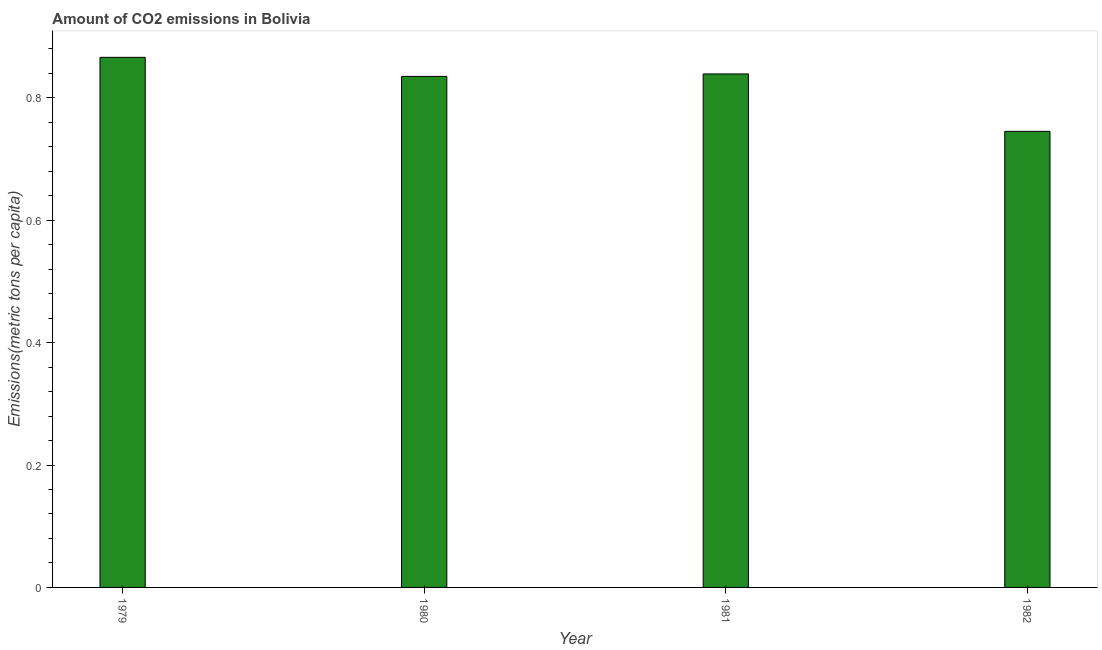Does the graph contain grids?
Ensure brevity in your answer.  No. What is the title of the graph?
Offer a very short reply. Amount of CO2 emissions in Bolivia. What is the label or title of the X-axis?
Give a very brief answer. Year. What is the label or title of the Y-axis?
Your answer should be very brief. Emissions(metric tons per capita). What is the amount of co2 emissions in 1981?
Provide a short and direct response. 0.84. Across all years, what is the maximum amount of co2 emissions?
Make the answer very short. 0.87. Across all years, what is the minimum amount of co2 emissions?
Make the answer very short. 0.75. In which year was the amount of co2 emissions maximum?
Ensure brevity in your answer.  1979. What is the sum of the amount of co2 emissions?
Provide a short and direct response. 3.29. What is the difference between the amount of co2 emissions in 1980 and 1982?
Keep it short and to the point. 0.09. What is the average amount of co2 emissions per year?
Your response must be concise. 0.82. What is the median amount of co2 emissions?
Give a very brief answer. 0.84. In how many years, is the amount of co2 emissions greater than 0.32 metric tons per capita?
Your answer should be very brief. 4. What is the ratio of the amount of co2 emissions in 1981 to that in 1982?
Offer a terse response. 1.13. Is the amount of co2 emissions in 1980 less than that in 1982?
Ensure brevity in your answer.  No. Is the difference between the amount of co2 emissions in 1980 and 1982 greater than the difference between any two years?
Offer a terse response. No. What is the difference between the highest and the second highest amount of co2 emissions?
Offer a very short reply. 0.03. Is the sum of the amount of co2 emissions in 1980 and 1981 greater than the maximum amount of co2 emissions across all years?
Provide a succinct answer. Yes. What is the difference between the highest and the lowest amount of co2 emissions?
Offer a very short reply. 0.12. In how many years, is the amount of co2 emissions greater than the average amount of co2 emissions taken over all years?
Your response must be concise. 3. How many bars are there?
Provide a short and direct response. 4. How many years are there in the graph?
Your response must be concise. 4. What is the Emissions(metric tons per capita) in 1979?
Give a very brief answer. 0.87. What is the Emissions(metric tons per capita) of 1980?
Give a very brief answer. 0.84. What is the Emissions(metric tons per capita) of 1981?
Offer a very short reply. 0.84. What is the Emissions(metric tons per capita) in 1982?
Ensure brevity in your answer.  0.75. What is the difference between the Emissions(metric tons per capita) in 1979 and 1980?
Give a very brief answer. 0.03. What is the difference between the Emissions(metric tons per capita) in 1979 and 1981?
Offer a very short reply. 0.03. What is the difference between the Emissions(metric tons per capita) in 1979 and 1982?
Your response must be concise. 0.12. What is the difference between the Emissions(metric tons per capita) in 1980 and 1981?
Your answer should be very brief. -0. What is the difference between the Emissions(metric tons per capita) in 1980 and 1982?
Offer a terse response. 0.09. What is the difference between the Emissions(metric tons per capita) in 1981 and 1982?
Provide a succinct answer. 0.09. What is the ratio of the Emissions(metric tons per capita) in 1979 to that in 1981?
Your response must be concise. 1.03. What is the ratio of the Emissions(metric tons per capita) in 1979 to that in 1982?
Offer a terse response. 1.16. What is the ratio of the Emissions(metric tons per capita) in 1980 to that in 1981?
Provide a short and direct response. 0.99. What is the ratio of the Emissions(metric tons per capita) in 1980 to that in 1982?
Give a very brief answer. 1.12. What is the ratio of the Emissions(metric tons per capita) in 1981 to that in 1982?
Give a very brief answer. 1.13. 